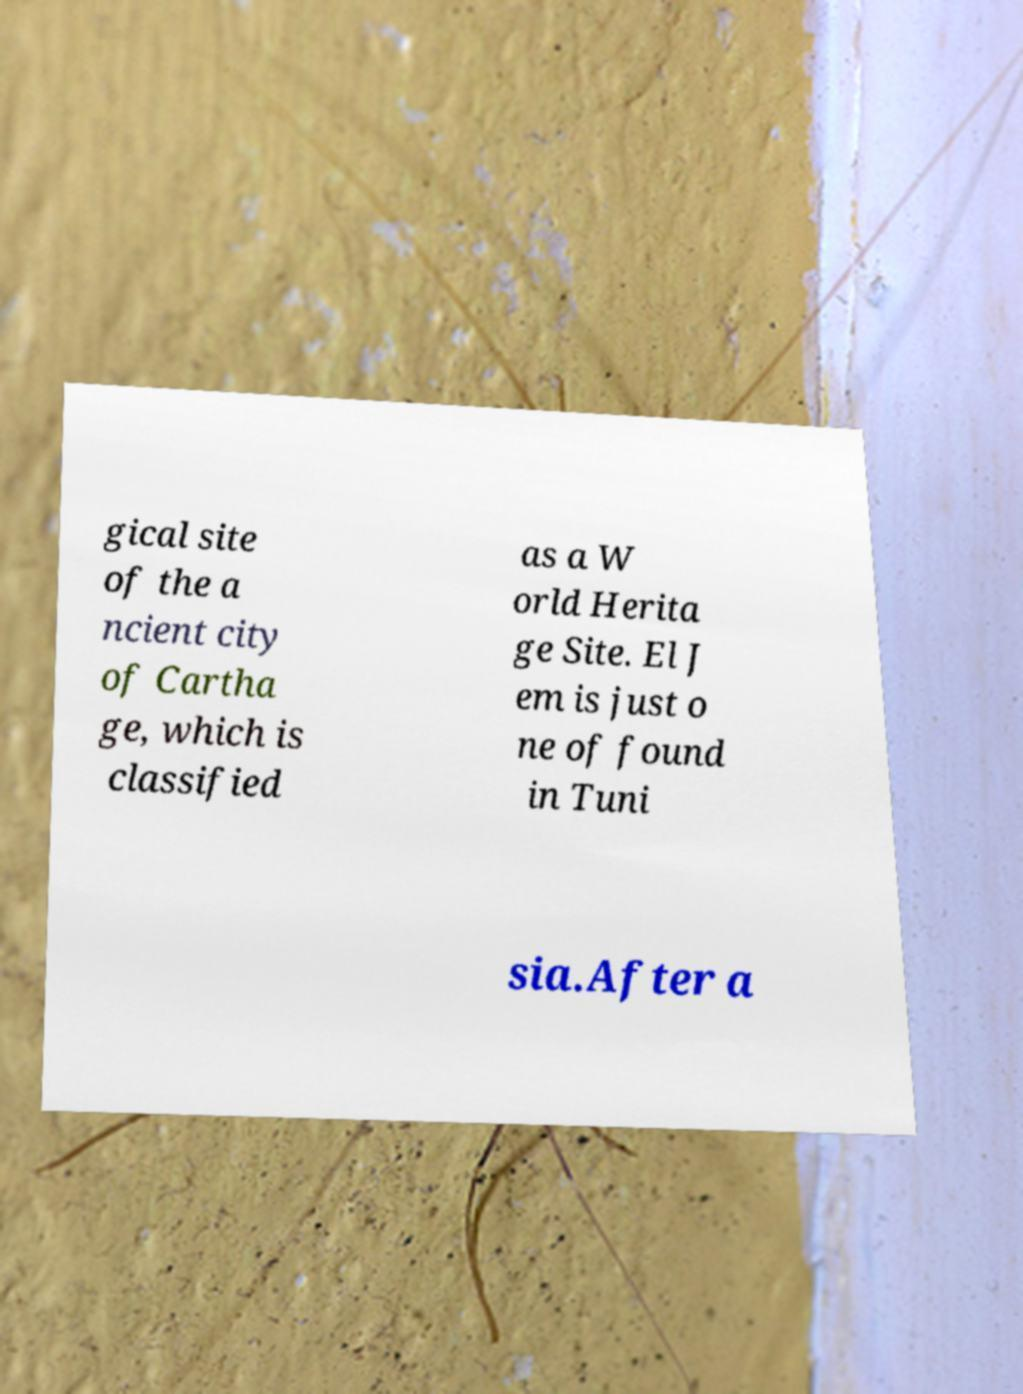For documentation purposes, I need the text within this image transcribed. Could you provide that? gical site of the a ncient city of Cartha ge, which is classified as a W orld Herita ge Site. El J em is just o ne of found in Tuni sia.After a 